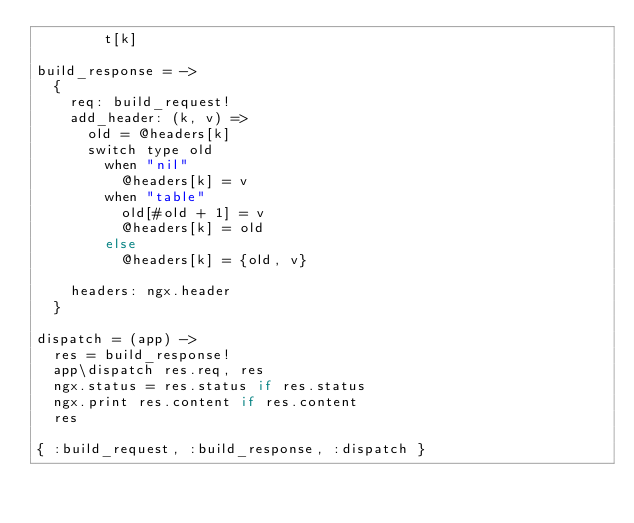<code> <loc_0><loc_0><loc_500><loc_500><_MoonScript_>        t[k]

build_response = ->
  {
    req: build_request!
    add_header: (k, v) =>
      old = @headers[k]
      switch type old
        when "nil"
          @headers[k] = v
        when "table"
          old[#old + 1] = v
          @headers[k] = old
        else
          @headers[k] = {old, v}

    headers: ngx.header
  }

dispatch = (app) ->
  res = build_response!
  app\dispatch res.req, res
  ngx.status = res.status if res.status
  ngx.print res.content if res.content
  res

{ :build_request, :build_response, :dispatch }


</code> 